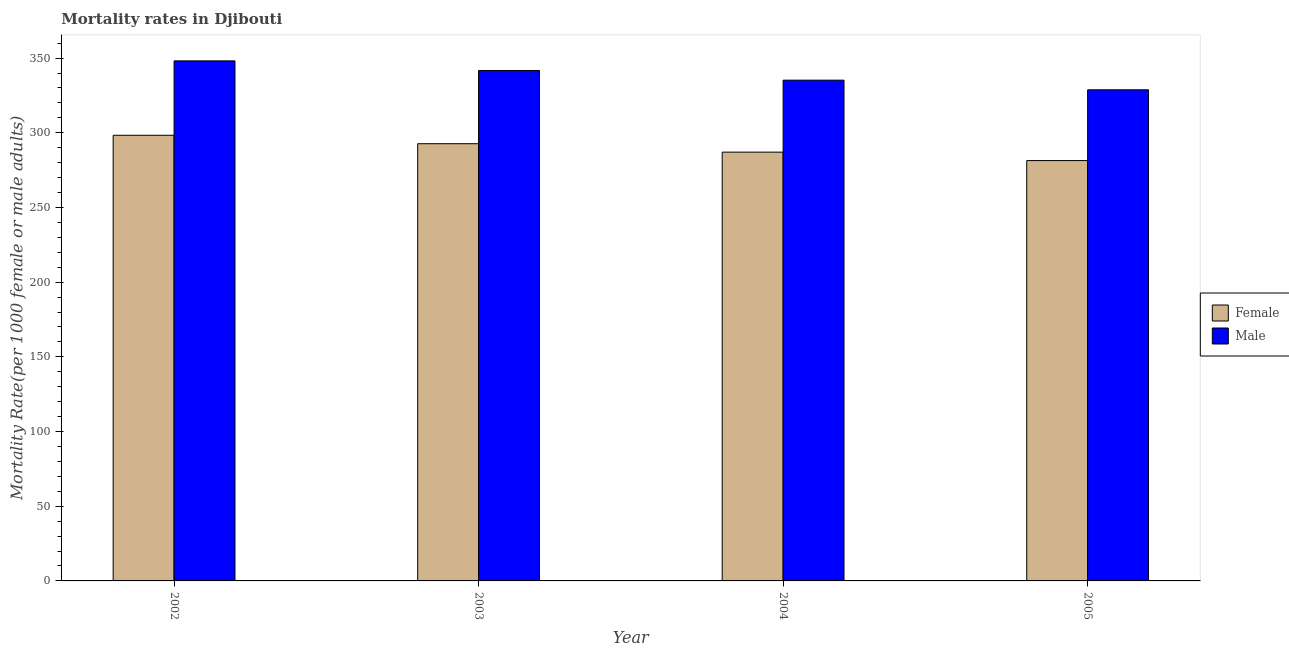How many groups of bars are there?
Your answer should be compact. 4. Are the number of bars on each tick of the X-axis equal?
Ensure brevity in your answer.  Yes. How many bars are there on the 1st tick from the left?
Keep it short and to the point. 2. How many bars are there on the 3rd tick from the right?
Provide a succinct answer. 2. What is the male mortality rate in 2002?
Offer a terse response. 348.13. Across all years, what is the maximum male mortality rate?
Provide a short and direct response. 348.13. Across all years, what is the minimum male mortality rate?
Give a very brief answer. 328.77. In which year was the male mortality rate maximum?
Your answer should be compact. 2002. In which year was the male mortality rate minimum?
Your answer should be compact. 2005. What is the total male mortality rate in the graph?
Keep it short and to the point. 1353.82. What is the difference between the female mortality rate in 2002 and that in 2004?
Offer a very short reply. 11.28. What is the difference between the female mortality rate in 2004 and the male mortality rate in 2002?
Make the answer very short. -11.28. What is the average female mortality rate per year?
Offer a very short reply. 289.86. In the year 2005, what is the difference between the male mortality rate and female mortality rate?
Your answer should be very brief. 0. In how many years, is the male mortality rate greater than 330?
Provide a short and direct response. 3. What is the ratio of the male mortality rate in 2002 to that in 2004?
Offer a very short reply. 1.04. Is the male mortality rate in 2002 less than that in 2005?
Offer a terse response. No. Is the difference between the male mortality rate in 2002 and 2005 greater than the difference between the female mortality rate in 2002 and 2005?
Your answer should be very brief. No. What is the difference between the highest and the second highest female mortality rate?
Provide a short and direct response. 5.64. What is the difference between the highest and the lowest male mortality rate?
Offer a terse response. 19.36. What does the 1st bar from the left in 2002 represents?
Provide a succinct answer. Female. Are all the bars in the graph horizontal?
Your answer should be compact. No. Are the values on the major ticks of Y-axis written in scientific E-notation?
Offer a terse response. No. Does the graph contain any zero values?
Keep it short and to the point. No. Does the graph contain grids?
Your answer should be compact. No. Where does the legend appear in the graph?
Give a very brief answer. Center right. How are the legend labels stacked?
Offer a very short reply. Vertical. What is the title of the graph?
Offer a very short reply. Mortality rates in Djibouti. What is the label or title of the Y-axis?
Offer a terse response. Mortality Rate(per 1000 female or male adults). What is the Mortality Rate(per 1000 female or male adults) in Female in 2002?
Your answer should be compact. 298.33. What is the Mortality Rate(per 1000 female or male adults) of Male in 2002?
Keep it short and to the point. 348.13. What is the Mortality Rate(per 1000 female or male adults) in Female in 2003?
Ensure brevity in your answer.  292.69. What is the Mortality Rate(per 1000 female or male adults) in Male in 2003?
Make the answer very short. 341.68. What is the Mortality Rate(per 1000 female or male adults) of Female in 2004?
Your response must be concise. 287.04. What is the Mortality Rate(per 1000 female or male adults) of Male in 2004?
Provide a short and direct response. 335.23. What is the Mortality Rate(per 1000 female or male adults) in Female in 2005?
Give a very brief answer. 281.4. What is the Mortality Rate(per 1000 female or male adults) of Male in 2005?
Provide a short and direct response. 328.77. Across all years, what is the maximum Mortality Rate(per 1000 female or male adults) of Female?
Offer a terse response. 298.33. Across all years, what is the maximum Mortality Rate(per 1000 female or male adults) in Male?
Keep it short and to the point. 348.13. Across all years, what is the minimum Mortality Rate(per 1000 female or male adults) in Female?
Your response must be concise. 281.4. Across all years, what is the minimum Mortality Rate(per 1000 female or male adults) in Male?
Your answer should be compact. 328.77. What is the total Mortality Rate(per 1000 female or male adults) of Female in the graph?
Give a very brief answer. 1159.46. What is the total Mortality Rate(per 1000 female or male adults) of Male in the graph?
Provide a short and direct response. 1353.82. What is the difference between the Mortality Rate(per 1000 female or male adults) in Female in 2002 and that in 2003?
Ensure brevity in your answer.  5.64. What is the difference between the Mortality Rate(per 1000 female or male adults) of Male in 2002 and that in 2003?
Keep it short and to the point. 6.45. What is the difference between the Mortality Rate(per 1000 female or male adults) of Female in 2002 and that in 2004?
Keep it short and to the point. 11.29. What is the difference between the Mortality Rate(per 1000 female or male adults) in Male in 2002 and that in 2004?
Your response must be concise. 12.91. What is the difference between the Mortality Rate(per 1000 female or male adults) of Female in 2002 and that in 2005?
Provide a succinct answer. 16.93. What is the difference between the Mortality Rate(per 1000 female or male adults) in Male in 2002 and that in 2005?
Provide a short and direct response. 19.36. What is the difference between the Mortality Rate(per 1000 female or male adults) in Female in 2003 and that in 2004?
Provide a short and direct response. 5.64. What is the difference between the Mortality Rate(per 1000 female or male adults) of Male in 2003 and that in 2004?
Make the answer very short. 6.45. What is the difference between the Mortality Rate(per 1000 female or male adults) of Female in 2003 and that in 2005?
Keep it short and to the point. 11.29. What is the difference between the Mortality Rate(per 1000 female or male adults) of Male in 2003 and that in 2005?
Your answer should be very brief. 12.91. What is the difference between the Mortality Rate(per 1000 female or male adults) of Female in 2004 and that in 2005?
Offer a terse response. 5.64. What is the difference between the Mortality Rate(per 1000 female or male adults) in Male in 2004 and that in 2005?
Your answer should be compact. 6.45. What is the difference between the Mortality Rate(per 1000 female or male adults) in Female in 2002 and the Mortality Rate(per 1000 female or male adults) in Male in 2003?
Provide a short and direct response. -43.35. What is the difference between the Mortality Rate(per 1000 female or male adults) of Female in 2002 and the Mortality Rate(per 1000 female or male adults) of Male in 2004?
Provide a short and direct response. -36.9. What is the difference between the Mortality Rate(per 1000 female or male adults) in Female in 2002 and the Mortality Rate(per 1000 female or male adults) in Male in 2005?
Your response must be concise. -30.45. What is the difference between the Mortality Rate(per 1000 female or male adults) in Female in 2003 and the Mortality Rate(per 1000 female or male adults) in Male in 2004?
Give a very brief answer. -42.54. What is the difference between the Mortality Rate(per 1000 female or male adults) in Female in 2003 and the Mortality Rate(per 1000 female or male adults) in Male in 2005?
Ensure brevity in your answer.  -36.09. What is the difference between the Mortality Rate(per 1000 female or male adults) in Female in 2004 and the Mortality Rate(per 1000 female or male adults) in Male in 2005?
Ensure brevity in your answer.  -41.73. What is the average Mortality Rate(per 1000 female or male adults) in Female per year?
Keep it short and to the point. 289.86. What is the average Mortality Rate(per 1000 female or male adults) of Male per year?
Give a very brief answer. 338.45. In the year 2002, what is the difference between the Mortality Rate(per 1000 female or male adults) in Female and Mortality Rate(per 1000 female or male adults) in Male?
Offer a very short reply. -49.81. In the year 2003, what is the difference between the Mortality Rate(per 1000 female or male adults) of Female and Mortality Rate(per 1000 female or male adults) of Male?
Ensure brevity in your answer.  -48.99. In the year 2004, what is the difference between the Mortality Rate(per 1000 female or male adults) in Female and Mortality Rate(per 1000 female or male adults) in Male?
Your response must be concise. -48.19. In the year 2005, what is the difference between the Mortality Rate(per 1000 female or male adults) of Female and Mortality Rate(per 1000 female or male adults) of Male?
Keep it short and to the point. -47.37. What is the ratio of the Mortality Rate(per 1000 female or male adults) in Female in 2002 to that in 2003?
Ensure brevity in your answer.  1.02. What is the ratio of the Mortality Rate(per 1000 female or male adults) in Male in 2002 to that in 2003?
Keep it short and to the point. 1.02. What is the ratio of the Mortality Rate(per 1000 female or male adults) in Female in 2002 to that in 2004?
Make the answer very short. 1.04. What is the ratio of the Mortality Rate(per 1000 female or male adults) in Male in 2002 to that in 2004?
Make the answer very short. 1.04. What is the ratio of the Mortality Rate(per 1000 female or male adults) of Female in 2002 to that in 2005?
Offer a very short reply. 1.06. What is the ratio of the Mortality Rate(per 1000 female or male adults) of Male in 2002 to that in 2005?
Provide a succinct answer. 1.06. What is the ratio of the Mortality Rate(per 1000 female or male adults) of Female in 2003 to that in 2004?
Your answer should be very brief. 1.02. What is the ratio of the Mortality Rate(per 1000 female or male adults) in Male in 2003 to that in 2004?
Your answer should be compact. 1.02. What is the ratio of the Mortality Rate(per 1000 female or male adults) of Female in 2003 to that in 2005?
Ensure brevity in your answer.  1.04. What is the ratio of the Mortality Rate(per 1000 female or male adults) of Male in 2003 to that in 2005?
Your response must be concise. 1.04. What is the ratio of the Mortality Rate(per 1000 female or male adults) in Female in 2004 to that in 2005?
Keep it short and to the point. 1.02. What is the ratio of the Mortality Rate(per 1000 female or male adults) in Male in 2004 to that in 2005?
Provide a short and direct response. 1.02. What is the difference between the highest and the second highest Mortality Rate(per 1000 female or male adults) in Female?
Your answer should be very brief. 5.64. What is the difference between the highest and the second highest Mortality Rate(per 1000 female or male adults) in Male?
Offer a very short reply. 6.45. What is the difference between the highest and the lowest Mortality Rate(per 1000 female or male adults) in Female?
Your answer should be very brief. 16.93. What is the difference between the highest and the lowest Mortality Rate(per 1000 female or male adults) in Male?
Offer a very short reply. 19.36. 